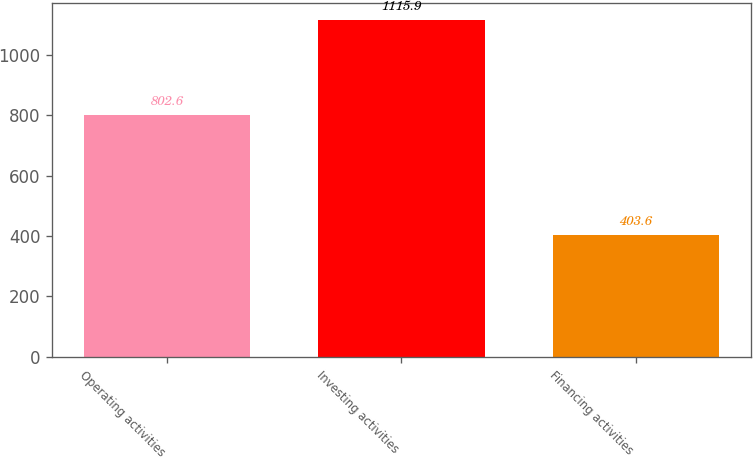Convert chart to OTSL. <chart><loc_0><loc_0><loc_500><loc_500><bar_chart><fcel>Operating activities<fcel>Investing activities<fcel>Financing activities<nl><fcel>802.6<fcel>1115.9<fcel>403.6<nl></chart> 